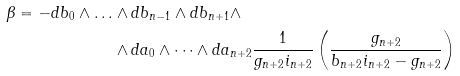<formula> <loc_0><loc_0><loc_500><loc_500>\beta = - d b _ { 0 } \wedge \dots & \wedge d b _ { n - 1 } \wedge d b _ { n + 1 } \wedge \\ & \wedge d a _ { 0 } \wedge \dots \wedge d a _ { n + 2 } \frac { 1 } { g _ { n + 2 } i _ { n + 2 } } \left ( \frac { g _ { n + 2 } } { b _ { n + 2 } i _ { n + 2 } - g _ { n + 2 } } \right )</formula> 